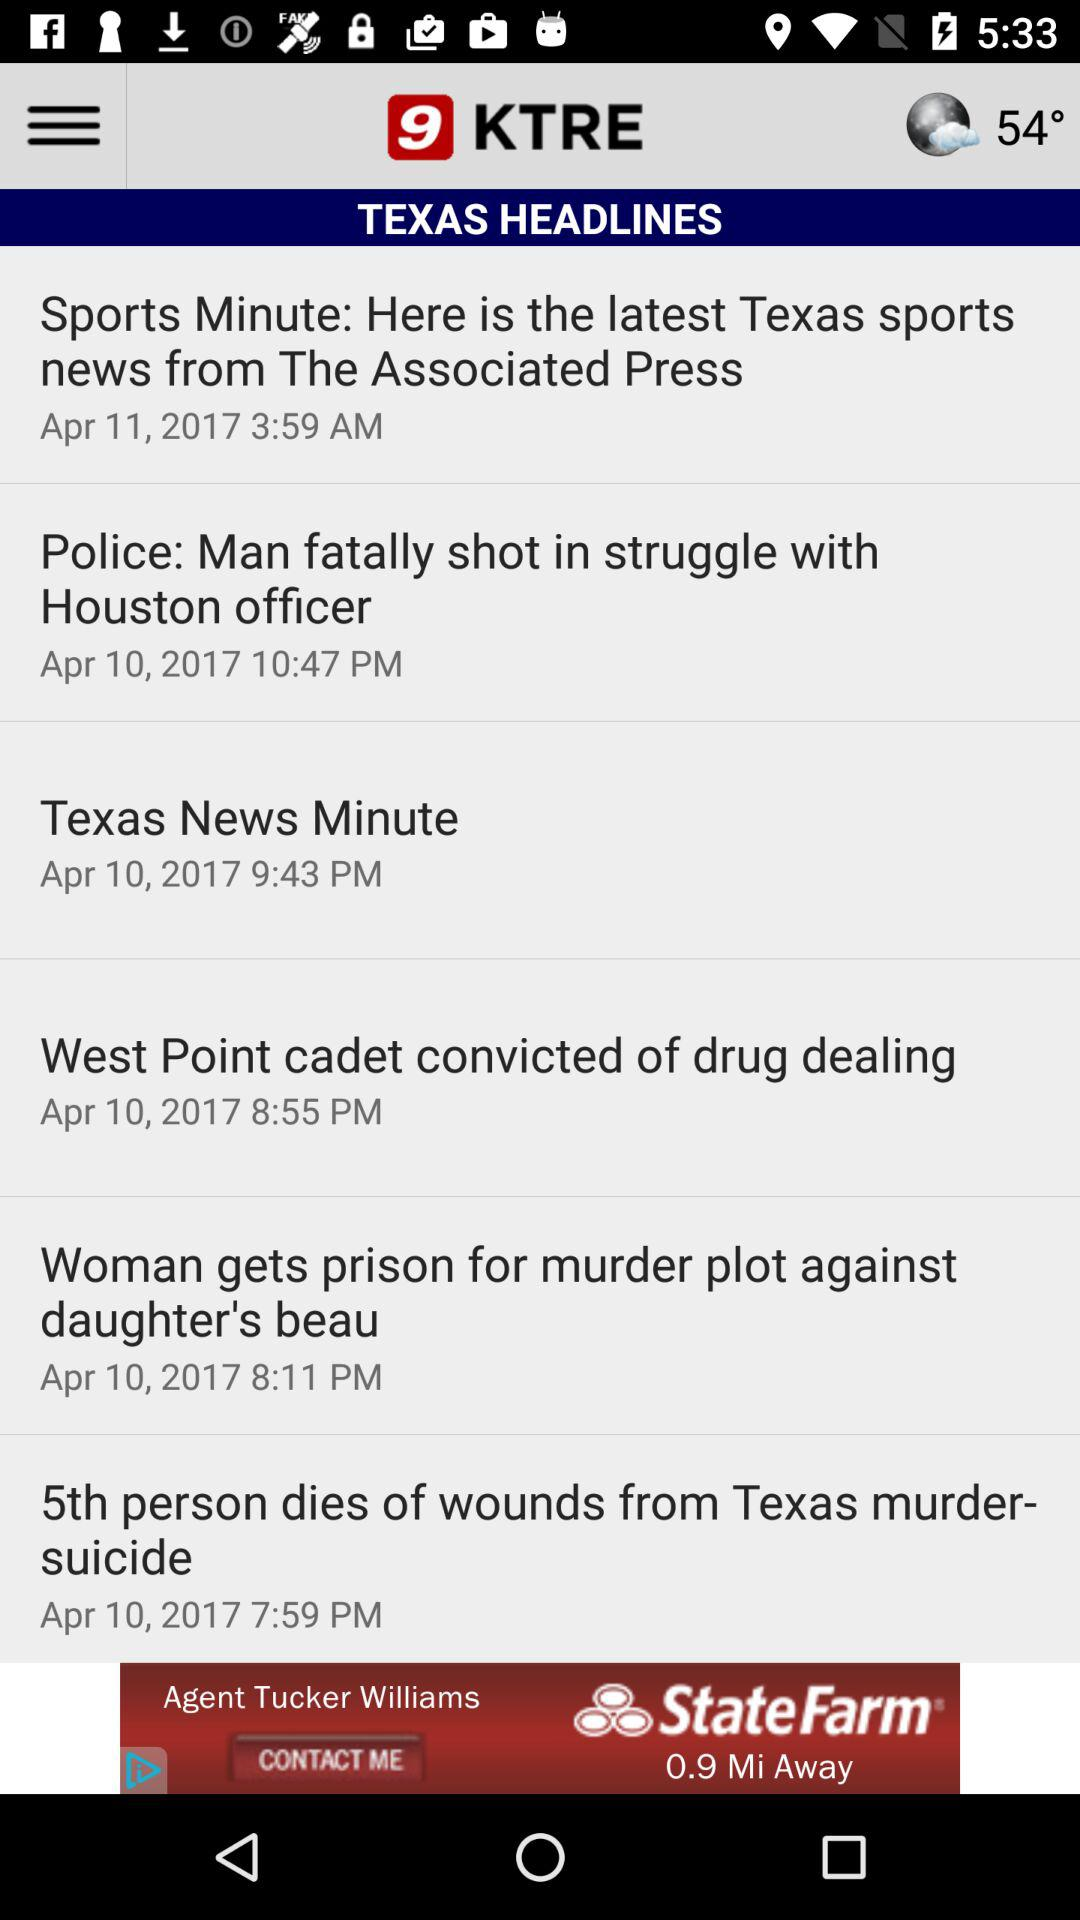Which headline was published on April 10, 2017 at 9:43 p.m.? The headline "Texas News Minute" was published on April 10, 2017 at 9:43 p.m. 